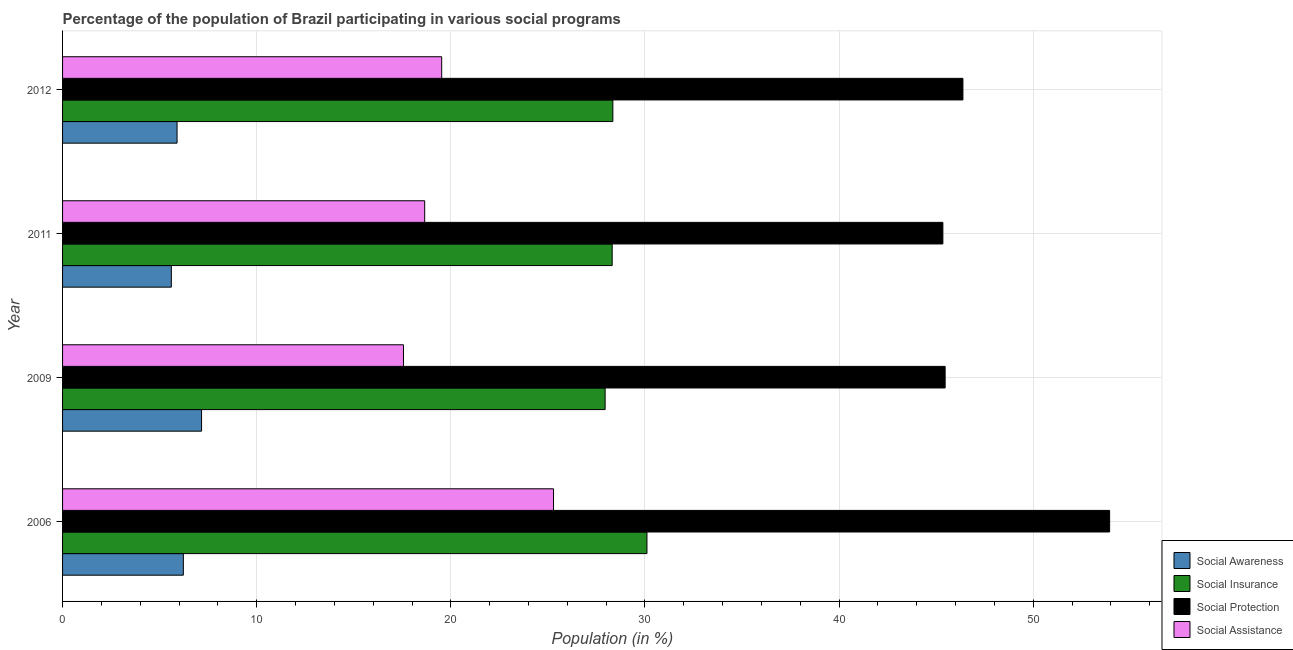How many different coloured bars are there?
Your answer should be compact. 4. How many groups of bars are there?
Offer a terse response. 4. Are the number of bars on each tick of the Y-axis equal?
Your response must be concise. Yes. How many bars are there on the 2nd tick from the bottom?
Provide a short and direct response. 4. In how many cases, is the number of bars for a given year not equal to the number of legend labels?
Your answer should be compact. 0. What is the participation of population in social assistance programs in 2011?
Provide a short and direct response. 18.65. Across all years, what is the maximum participation of population in social assistance programs?
Ensure brevity in your answer.  25.29. Across all years, what is the minimum participation of population in social assistance programs?
Provide a succinct answer. 17.56. In which year was the participation of population in social awareness programs maximum?
Your answer should be compact. 2009. In which year was the participation of population in social insurance programs minimum?
Make the answer very short. 2009. What is the total participation of population in social assistance programs in the graph?
Your answer should be very brief. 81.03. What is the difference between the participation of population in social assistance programs in 2011 and that in 2012?
Give a very brief answer. -0.88. What is the difference between the participation of population in social awareness programs in 2009 and the participation of population in social insurance programs in 2011?
Ensure brevity in your answer.  -21.15. What is the average participation of population in social protection programs per year?
Offer a terse response. 47.78. In the year 2006, what is the difference between the participation of population in social insurance programs and participation of population in social awareness programs?
Keep it short and to the point. 23.88. In how many years, is the participation of population in social awareness programs greater than 32 %?
Your answer should be compact. 0. What is the ratio of the participation of population in social awareness programs in 2009 to that in 2011?
Make the answer very short. 1.28. What is the difference between the highest and the second highest participation of population in social awareness programs?
Give a very brief answer. 0.94. What is the difference between the highest and the lowest participation of population in social awareness programs?
Make the answer very short. 1.56. Is it the case that in every year, the sum of the participation of population in social insurance programs and participation of population in social assistance programs is greater than the sum of participation of population in social protection programs and participation of population in social awareness programs?
Make the answer very short. Yes. What does the 3rd bar from the top in 2011 represents?
Your answer should be compact. Social Insurance. What does the 2nd bar from the bottom in 2011 represents?
Give a very brief answer. Social Insurance. How many bars are there?
Your answer should be compact. 16. Are all the bars in the graph horizontal?
Your answer should be very brief. Yes. What is the difference between two consecutive major ticks on the X-axis?
Your response must be concise. 10. Are the values on the major ticks of X-axis written in scientific E-notation?
Offer a terse response. No. How many legend labels are there?
Ensure brevity in your answer.  4. How are the legend labels stacked?
Provide a succinct answer. Vertical. What is the title of the graph?
Make the answer very short. Percentage of the population of Brazil participating in various social programs . Does "Secondary vocational education" appear as one of the legend labels in the graph?
Provide a succinct answer. No. What is the Population (in %) in Social Awareness in 2006?
Keep it short and to the point. 6.22. What is the Population (in %) of Social Insurance in 2006?
Give a very brief answer. 30.1. What is the Population (in %) of Social Protection in 2006?
Keep it short and to the point. 53.93. What is the Population (in %) in Social Assistance in 2006?
Ensure brevity in your answer.  25.29. What is the Population (in %) in Social Awareness in 2009?
Your response must be concise. 7.16. What is the Population (in %) of Social Insurance in 2009?
Your answer should be compact. 27.95. What is the Population (in %) of Social Protection in 2009?
Offer a terse response. 45.46. What is the Population (in %) in Social Assistance in 2009?
Give a very brief answer. 17.56. What is the Population (in %) in Social Awareness in 2011?
Offer a terse response. 5.6. What is the Population (in %) of Social Insurance in 2011?
Your response must be concise. 28.31. What is the Population (in %) of Social Protection in 2011?
Offer a very short reply. 45.34. What is the Population (in %) of Social Assistance in 2011?
Offer a terse response. 18.65. What is the Population (in %) of Social Awareness in 2012?
Provide a succinct answer. 5.9. What is the Population (in %) in Social Insurance in 2012?
Offer a terse response. 28.34. What is the Population (in %) of Social Protection in 2012?
Keep it short and to the point. 46.38. What is the Population (in %) of Social Assistance in 2012?
Offer a terse response. 19.53. Across all years, what is the maximum Population (in %) in Social Awareness?
Offer a terse response. 7.16. Across all years, what is the maximum Population (in %) in Social Insurance?
Your answer should be compact. 30.1. Across all years, what is the maximum Population (in %) of Social Protection?
Give a very brief answer. 53.93. Across all years, what is the maximum Population (in %) in Social Assistance?
Your response must be concise. 25.29. Across all years, what is the minimum Population (in %) of Social Awareness?
Keep it short and to the point. 5.6. Across all years, what is the minimum Population (in %) in Social Insurance?
Provide a succinct answer. 27.95. Across all years, what is the minimum Population (in %) of Social Protection?
Offer a very short reply. 45.34. Across all years, what is the minimum Population (in %) in Social Assistance?
Give a very brief answer. 17.56. What is the total Population (in %) of Social Awareness in the graph?
Ensure brevity in your answer.  24.88. What is the total Population (in %) of Social Insurance in the graph?
Give a very brief answer. 114.7. What is the total Population (in %) in Social Protection in the graph?
Provide a succinct answer. 191.11. What is the total Population (in %) of Social Assistance in the graph?
Make the answer very short. 81.03. What is the difference between the Population (in %) of Social Awareness in 2006 and that in 2009?
Ensure brevity in your answer.  -0.94. What is the difference between the Population (in %) of Social Insurance in 2006 and that in 2009?
Your answer should be very brief. 2.15. What is the difference between the Population (in %) of Social Protection in 2006 and that in 2009?
Your answer should be compact. 8.47. What is the difference between the Population (in %) of Social Assistance in 2006 and that in 2009?
Make the answer very short. 7.73. What is the difference between the Population (in %) in Social Awareness in 2006 and that in 2011?
Ensure brevity in your answer.  0.62. What is the difference between the Population (in %) in Social Insurance in 2006 and that in 2011?
Make the answer very short. 1.79. What is the difference between the Population (in %) of Social Protection in 2006 and that in 2011?
Your response must be concise. 8.59. What is the difference between the Population (in %) of Social Assistance in 2006 and that in 2011?
Provide a short and direct response. 6.64. What is the difference between the Population (in %) in Social Awareness in 2006 and that in 2012?
Your answer should be very brief. 0.32. What is the difference between the Population (in %) of Social Insurance in 2006 and that in 2012?
Provide a short and direct response. 1.76. What is the difference between the Population (in %) of Social Protection in 2006 and that in 2012?
Ensure brevity in your answer.  7.56. What is the difference between the Population (in %) of Social Assistance in 2006 and that in 2012?
Provide a short and direct response. 5.76. What is the difference between the Population (in %) in Social Awareness in 2009 and that in 2011?
Your answer should be compact. 1.56. What is the difference between the Population (in %) in Social Insurance in 2009 and that in 2011?
Your answer should be very brief. -0.36. What is the difference between the Population (in %) of Social Protection in 2009 and that in 2011?
Provide a succinct answer. 0.12. What is the difference between the Population (in %) in Social Assistance in 2009 and that in 2011?
Ensure brevity in your answer.  -1.09. What is the difference between the Population (in %) in Social Awareness in 2009 and that in 2012?
Provide a succinct answer. 1.26. What is the difference between the Population (in %) in Social Insurance in 2009 and that in 2012?
Give a very brief answer. -0.4. What is the difference between the Population (in %) in Social Protection in 2009 and that in 2012?
Ensure brevity in your answer.  -0.92. What is the difference between the Population (in %) of Social Assistance in 2009 and that in 2012?
Give a very brief answer. -1.97. What is the difference between the Population (in %) in Social Awareness in 2011 and that in 2012?
Your response must be concise. -0.3. What is the difference between the Population (in %) of Social Insurance in 2011 and that in 2012?
Your response must be concise. -0.03. What is the difference between the Population (in %) of Social Protection in 2011 and that in 2012?
Your answer should be very brief. -1.03. What is the difference between the Population (in %) in Social Assistance in 2011 and that in 2012?
Your answer should be compact. -0.88. What is the difference between the Population (in %) in Social Awareness in 2006 and the Population (in %) in Social Insurance in 2009?
Your answer should be very brief. -21.73. What is the difference between the Population (in %) of Social Awareness in 2006 and the Population (in %) of Social Protection in 2009?
Offer a terse response. -39.24. What is the difference between the Population (in %) in Social Awareness in 2006 and the Population (in %) in Social Assistance in 2009?
Provide a succinct answer. -11.34. What is the difference between the Population (in %) of Social Insurance in 2006 and the Population (in %) of Social Protection in 2009?
Your answer should be compact. -15.36. What is the difference between the Population (in %) of Social Insurance in 2006 and the Population (in %) of Social Assistance in 2009?
Offer a very short reply. 12.54. What is the difference between the Population (in %) in Social Protection in 2006 and the Population (in %) in Social Assistance in 2009?
Offer a very short reply. 36.37. What is the difference between the Population (in %) of Social Awareness in 2006 and the Population (in %) of Social Insurance in 2011?
Offer a very short reply. -22.09. What is the difference between the Population (in %) in Social Awareness in 2006 and the Population (in %) in Social Protection in 2011?
Give a very brief answer. -39.12. What is the difference between the Population (in %) of Social Awareness in 2006 and the Population (in %) of Social Assistance in 2011?
Keep it short and to the point. -12.43. What is the difference between the Population (in %) in Social Insurance in 2006 and the Population (in %) in Social Protection in 2011?
Your answer should be very brief. -15.24. What is the difference between the Population (in %) in Social Insurance in 2006 and the Population (in %) in Social Assistance in 2011?
Provide a succinct answer. 11.45. What is the difference between the Population (in %) in Social Protection in 2006 and the Population (in %) in Social Assistance in 2011?
Make the answer very short. 35.28. What is the difference between the Population (in %) of Social Awareness in 2006 and the Population (in %) of Social Insurance in 2012?
Keep it short and to the point. -22.12. What is the difference between the Population (in %) in Social Awareness in 2006 and the Population (in %) in Social Protection in 2012?
Give a very brief answer. -40.16. What is the difference between the Population (in %) of Social Awareness in 2006 and the Population (in %) of Social Assistance in 2012?
Offer a terse response. -13.31. What is the difference between the Population (in %) of Social Insurance in 2006 and the Population (in %) of Social Protection in 2012?
Offer a very short reply. -16.28. What is the difference between the Population (in %) in Social Insurance in 2006 and the Population (in %) in Social Assistance in 2012?
Provide a succinct answer. 10.57. What is the difference between the Population (in %) in Social Protection in 2006 and the Population (in %) in Social Assistance in 2012?
Offer a terse response. 34.4. What is the difference between the Population (in %) in Social Awareness in 2009 and the Population (in %) in Social Insurance in 2011?
Your response must be concise. -21.15. What is the difference between the Population (in %) in Social Awareness in 2009 and the Population (in %) in Social Protection in 2011?
Provide a succinct answer. -38.18. What is the difference between the Population (in %) of Social Awareness in 2009 and the Population (in %) of Social Assistance in 2011?
Make the answer very short. -11.49. What is the difference between the Population (in %) of Social Insurance in 2009 and the Population (in %) of Social Protection in 2011?
Offer a very short reply. -17.4. What is the difference between the Population (in %) in Social Insurance in 2009 and the Population (in %) in Social Assistance in 2011?
Ensure brevity in your answer.  9.29. What is the difference between the Population (in %) in Social Protection in 2009 and the Population (in %) in Social Assistance in 2011?
Your answer should be compact. 26.81. What is the difference between the Population (in %) of Social Awareness in 2009 and the Population (in %) of Social Insurance in 2012?
Provide a short and direct response. -21.18. What is the difference between the Population (in %) in Social Awareness in 2009 and the Population (in %) in Social Protection in 2012?
Give a very brief answer. -39.22. What is the difference between the Population (in %) of Social Awareness in 2009 and the Population (in %) of Social Assistance in 2012?
Provide a succinct answer. -12.37. What is the difference between the Population (in %) in Social Insurance in 2009 and the Population (in %) in Social Protection in 2012?
Offer a terse response. -18.43. What is the difference between the Population (in %) in Social Insurance in 2009 and the Population (in %) in Social Assistance in 2012?
Provide a succinct answer. 8.42. What is the difference between the Population (in %) in Social Protection in 2009 and the Population (in %) in Social Assistance in 2012?
Provide a short and direct response. 25.93. What is the difference between the Population (in %) in Social Awareness in 2011 and the Population (in %) in Social Insurance in 2012?
Offer a terse response. -22.74. What is the difference between the Population (in %) in Social Awareness in 2011 and the Population (in %) in Social Protection in 2012?
Provide a short and direct response. -40.77. What is the difference between the Population (in %) of Social Awareness in 2011 and the Population (in %) of Social Assistance in 2012?
Your answer should be compact. -13.93. What is the difference between the Population (in %) of Social Insurance in 2011 and the Population (in %) of Social Protection in 2012?
Your response must be concise. -18.07. What is the difference between the Population (in %) in Social Insurance in 2011 and the Population (in %) in Social Assistance in 2012?
Offer a very short reply. 8.78. What is the difference between the Population (in %) in Social Protection in 2011 and the Population (in %) in Social Assistance in 2012?
Your answer should be very brief. 25.82. What is the average Population (in %) in Social Awareness per year?
Make the answer very short. 6.22. What is the average Population (in %) of Social Insurance per year?
Keep it short and to the point. 28.68. What is the average Population (in %) of Social Protection per year?
Your answer should be compact. 47.78. What is the average Population (in %) of Social Assistance per year?
Offer a very short reply. 20.26. In the year 2006, what is the difference between the Population (in %) of Social Awareness and Population (in %) of Social Insurance?
Provide a short and direct response. -23.88. In the year 2006, what is the difference between the Population (in %) of Social Awareness and Population (in %) of Social Protection?
Make the answer very short. -47.71. In the year 2006, what is the difference between the Population (in %) in Social Awareness and Population (in %) in Social Assistance?
Offer a terse response. -19.07. In the year 2006, what is the difference between the Population (in %) in Social Insurance and Population (in %) in Social Protection?
Keep it short and to the point. -23.83. In the year 2006, what is the difference between the Population (in %) in Social Insurance and Population (in %) in Social Assistance?
Offer a terse response. 4.81. In the year 2006, what is the difference between the Population (in %) in Social Protection and Population (in %) in Social Assistance?
Your answer should be compact. 28.64. In the year 2009, what is the difference between the Population (in %) in Social Awareness and Population (in %) in Social Insurance?
Your answer should be very brief. -20.79. In the year 2009, what is the difference between the Population (in %) in Social Awareness and Population (in %) in Social Protection?
Your answer should be compact. -38.3. In the year 2009, what is the difference between the Population (in %) in Social Awareness and Population (in %) in Social Assistance?
Make the answer very short. -10.4. In the year 2009, what is the difference between the Population (in %) in Social Insurance and Population (in %) in Social Protection?
Your answer should be compact. -17.51. In the year 2009, what is the difference between the Population (in %) of Social Insurance and Population (in %) of Social Assistance?
Ensure brevity in your answer.  10.39. In the year 2009, what is the difference between the Population (in %) of Social Protection and Population (in %) of Social Assistance?
Provide a succinct answer. 27.9. In the year 2011, what is the difference between the Population (in %) in Social Awareness and Population (in %) in Social Insurance?
Keep it short and to the point. -22.71. In the year 2011, what is the difference between the Population (in %) of Social Awareness and Population (in %) of Social Protection?
Ensure brevity in your answer.  -39.74. In the year 2011, what is the difference between the Population (in %) of Social Awareness and Population (in %) of Social Assistance?
Provide a short and direct response. -13.05. In the year 2011, what is the difference between the Population (in %) of Social Insurance and Population (in %) of Social Protection?
Your answer should be compact. -17.03. In the year 2011, what is the difference between the Population (in %) of Social Insurance and Population (in %) of Social Assistance?
Keep it short and to the point. 9.66. In the year 2011, what is the difference between the Population (in %) of Social Protection and Population (in %) of Social Assistance?
Ensure brevity in your answer.  26.69. In the year 2012, what is the difference between the Population (in %) of Social Awareness and Population (in %) of Social Insurance?
Provide a succinct answer. -22.45. In the year 2012, what is the difference between the Population (in %) in Social Awareness and Population (in %) in Social Protection?
Your answer should be compact. -40.48. In the year 2012, what is the difference between the Population (in %) in Social Awareness and Population (in %) in Social Assistance?
Offer a very short reply. -13.63. In the year 2012, what is the difference between the Population (in %) of Social Insurance and Population (in %) of Social Protection?
Your answer should be very brief. -18.03. In the year 2012, what is the difference between the Population (in %) of Social Insurance and Population (in %) of Social Assistance?
Give a very brief answer. 8.82. In the year 2012, what is the difference between the Population (in %) of Social Protection and Population (in %) of Social Assistance?
Provide a short and direct response. 26.85. What is the ratio of the Population (in %) in Social Awareness in 2006 to that in 2009?
Your answer should be compact. 0.87. What is the ratio of the Population (in %) in Social Insurance in 2006 to that in 2009?
Your response must be concise. 1.08. What is the ratio of the Population (in %) of Social Protection in 2006 to that in 2009?
Offer a terse response. 1.19. What is the ratio of the Population (in %) of Social Assistance in 2006 to that in 2009?
Your response must be concise. 1.44. What is the ratio of the Population (in %) of Social Awareness in 2006 to that in 2011?
Your response must be concise. 1.11. What is the ratio of the Population (in %) in Social Insurance in 2006 to that in 2011?
Your answer should be very brief. 1.06. What is the ratio of the Population (in %) in Social Protection in 2006 to that in 2011?
Keep it short and to the point. 1.19. What is the ratio of the Population (in %) in Social Assistance in 2006 to that in 2011?
Provide a short and direct response. 1.36. What is the ratio of the Population (in %) of Social Awareness in 2006 to that in 2012?
Your answer should be very brief. 1.05. What is the ratio of the Population (in %) of Social Insurance in 2006 to that in 2012?
Provide a succinct answer. 1.06. What is the ratio of the Population (in %) of Social Protection in 2006 to that in 2012?
Give a very brief answer. 1.16. What is the ratio of the Population (in %) in Social Assistance in 2006 to that in 2012?
Offer a terse response. 1.29. What is the ratio of the Population (in %) of Social Awareness in 2009 to that in 2011?
Your response must be concise. 1.28. What is the ratio of the Population (in %) of Social Insurance in 2009 to that in 2011?
Your response must be concise. 0.99. What is the ratio of the Population (in %) of Social Protection in 2009 to that in 2011?
Your answer should be very brief. 1. What is the ratio of the Population (in %) of Social Assistance in 2009 to that in 2011?
Your answer should be very brief. 0.94. What is the ratio of the Population (in %) of Social Awareness in 2009 to that in 2012?
Offer a very short reply. 1.21. What is the ratio of the Population (in %) in Social Insurance in 2009 to that in 2012?
Make the answer very short. 0.99. What is the ratio of the Population (in %) in Social Protection in 2009 to that in 2012?
Offer a very short reply. 0.98. What is the ratio of the Population (in %) of Social Assistance in 2009 to that in 2012?
Provide a succinct answer. 0.9. What is the ratio of the Population (in %) of Social Awareness in 2011 to that in 2012?
Offer a terse response. 0.95. What is the ratio of the Population (in %) of Social Protection in 2011 to that in 2012?
Ensure brevity in your answer.  0.98. What is the ratio of the Population (in %) in Social Assistance in 2011 to that in 2012?
Keep it short and to the point. 0.96. What is the difference between the highest and the second highest Population (in %) of Social Awareness?
Ensure brevity in your answer.  0.94. What is the difference between the highest and the second highest Population (in %) of Social Insurance?
Provide a short and direct response. 1.76. What is the difference between the highest and the second highest Population (in %) in Social Protection?
Offer a terse response. 7.56. What is the difference between the highest and the second highest Population (in %) in Social Assistance?
Keep it short and to the point. 5.76. What is the difference between the highest and the lowest Population (in %) of Social Awareness?
Your answer should be compact. 1.56. What is the difference between the highest and the lowest Population (in %) of Social Insurance?
Keep it short and to the point. 2.15. What is the difference between the highest and the lowest Population (in %) in Social Protection?
Offer a terse response. 8.59. What is the difference between the highest and the lowest Population (in %) of Social Assistance?
Keep it short and to the point. 7.73. 